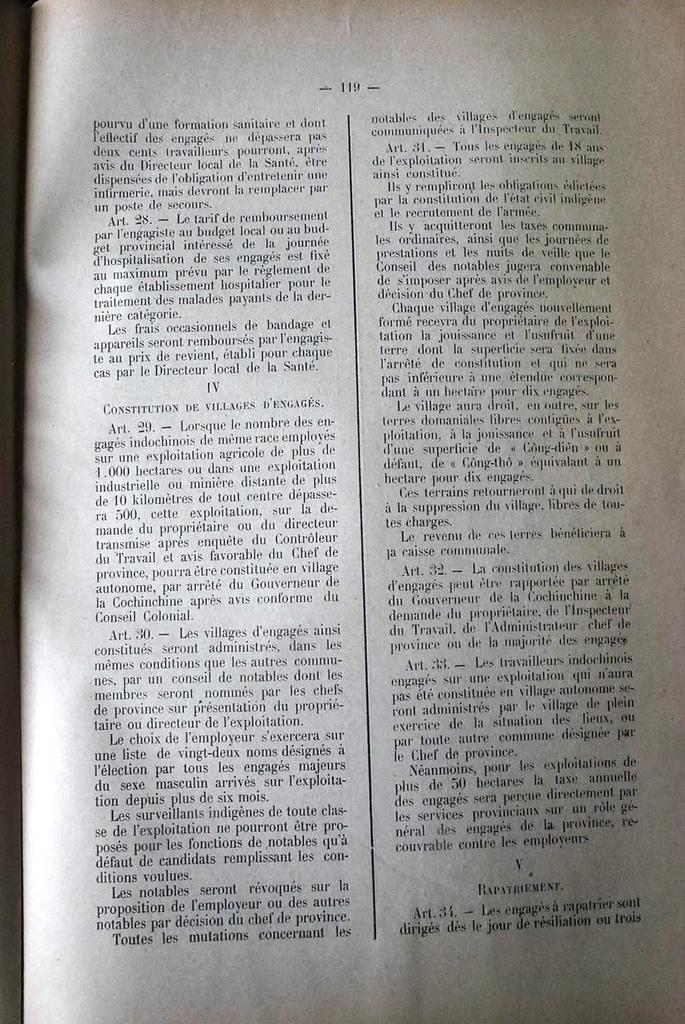<image>
Render a clear and concise summary of the photo. Book that shows about Constitution De Villages D'Emgages. 